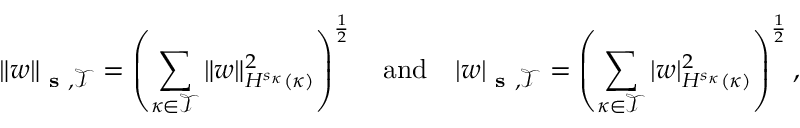<formula> <loc_0><loc_0><loc_500><loc_500>\| w \| _ { s , \mathcal { T } } = \left ( \sum _ { \kappa \in \mathcal { T } } \| w \| _ { H ^ { s _ { \kappa } } ( \kappa ) } ^ { 2 } \right ) ^ { \frac { 1 } { 2 } } \quad a n d \quad | w | _ { s , \mathcal { T } } = \left ( \sum _ { \kappa \in \mathcal { T } } | w | _ { H ^ { s _ { \kappa } } ( \kappa ) } ^ { 2 } \right ) ^ { \frac { 1 } { 2 } } ,</formula> 